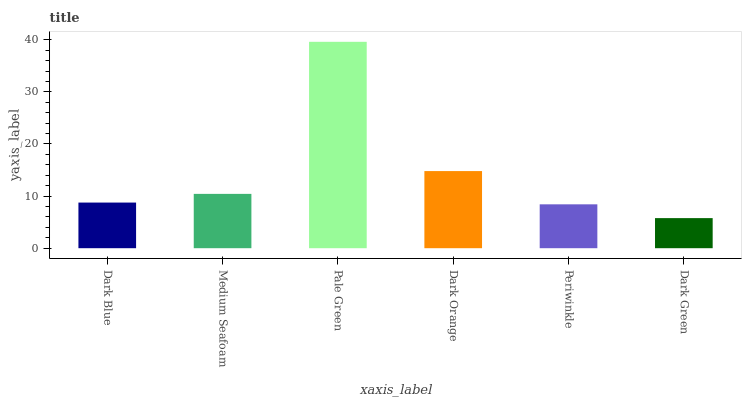Is Dark Green the minimum?
Answer yes or no. Yes. Is Pale Green the maximum?
Answer yes or no. Yes. Is Medium Seafoam the minimum?
Answer yes or no. No. Is Medium Seafoam the maximum?
Answer yes or no. No. Is Medium Seafoam greater than Dark Blue?
Answer yes or no. Yes. Is Dark Blue less than Medium Seafoam?
Answer yes or no. Yes. Is Dark Blue greater than Medium Seafoam?
Answer yes or no. No. Is Medium Seafoam less than Dark Blue?
Answer yes or no. No. Is Medium Seafoam the high median?
Answer yes or no. Yes. Is Dark Blue the low median?
Answer yes or no. Yes. Is Dark Orange the high median?
Answer yes or no. No. Is Periwinkle the low median?
Answer yes or no. No. 